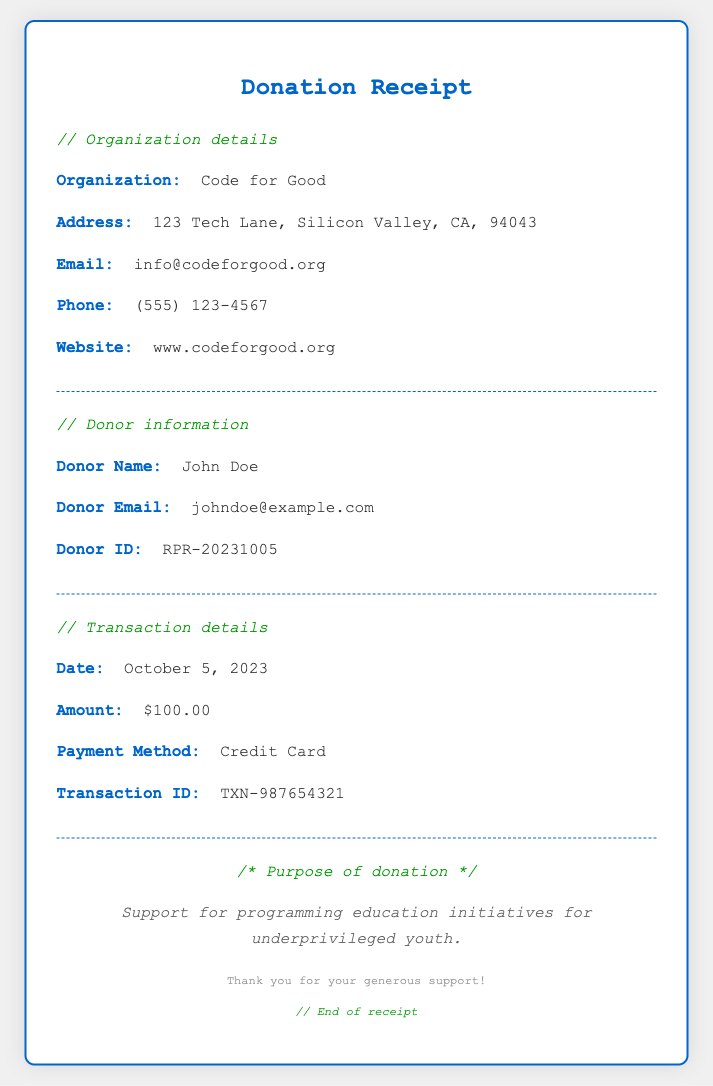What is the organization name? The organization name is mentioned in the heading and body of the document.
Answer: Code for Good What is the donation amount? The donation amount is clearly stated in the transaction details section.
Answer: $100.00 What is the donor's email address? The donor's email address is provided in the donor information section.
Answer: johndoe@example.com What is the transaction date? The transaction date can be found in the transaction details section.
Answer: October 5, 2023 What is the purpose of the donation? The purpose is specified in a designated section of the document.
Answer: Support for programming education initiatives for underprivileged youth How was the payment made? The payment method is indicated in the transaction details section.
Answer: Credit Card What is the donor ID? The donor ID is included in the donor information section.
Answer: RPR-20231005 What is the website of the organization? The organization's website is listed in the organization details.
Answer: www.codeforgood.org How can the organization be contacted? The organization's contact details, including phone and email, are presented in the document.
Answer: (555) 123-4567 What type of document is this? The document is a type of receipt related to charitable donations.
Answer: Donation Receipt 